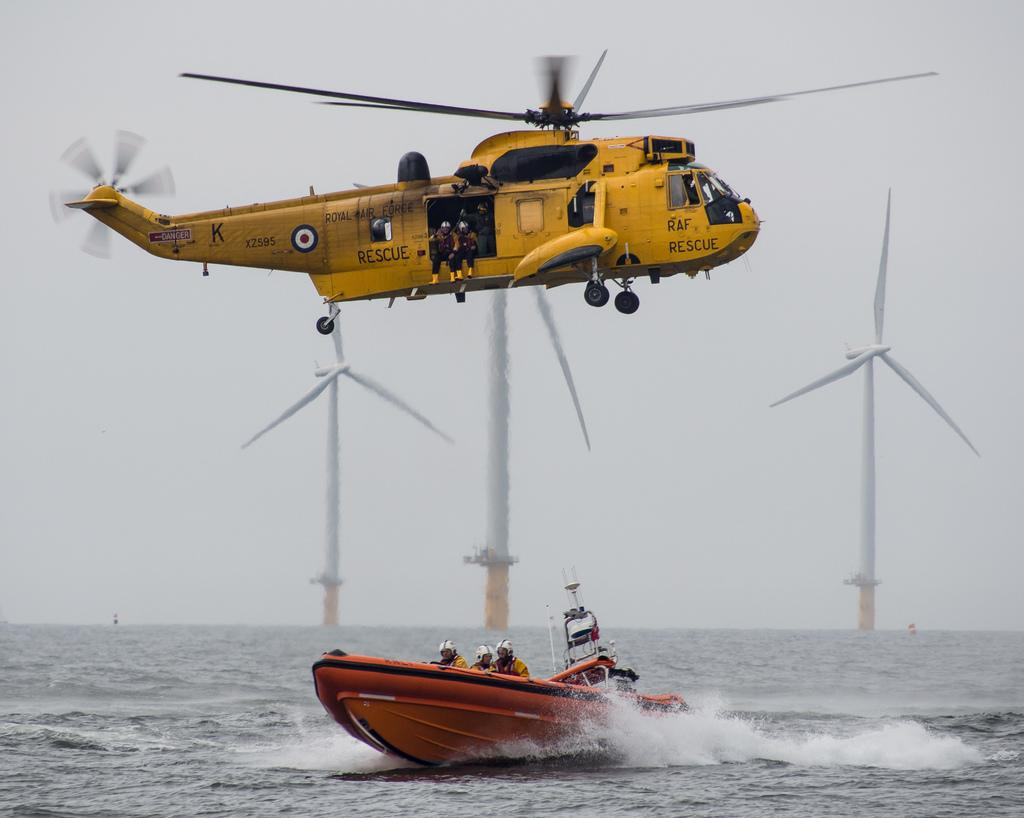What is flying in the image? There is a helicopter flying in the image. What is on the water in the image? There is a boat on the water in the image. Can you see any people in the image? Yes, there are people visible in the image. What structures can be seen in the image? There are windmills in the image. What is visible in the background of the image? The sky is visible in the background of the image. Where is the doctor's office located in the image? There is no doctor's office present in the image. Can you see any animals from the zoo in the image? There are no animals from a zoo present in the image. 